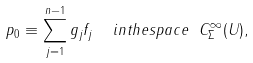<formula> <loc_0><loc_0><loc_500><loc_500>p _ { 0 } \equiv \sum ^ { n - 1 } _ { j = 1 } g _ { j } f _ { j } \ \ i n t h e s p a c e \ C ^ { \infty } _ { \Sigma } ( U ) ,</formula> 